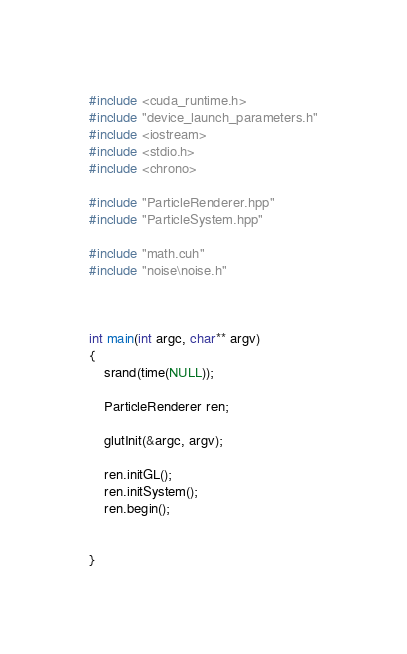Convert code to text. <code><loc_0><loc_0><loc_500><loc_500><_Cuda_>

#include <cuda_runtime.h>
#include "device_launch_parameters.h"
#include <iostream>
#include <stdio.h>
#include <chrono>

#include "ParticleRenderer.hpp"
#include "ParticleSystem.hpp"

#include "math.cuh"
#include "noise\noise.h"



int main(int argc, char** argv)
{
	srand(time(NULL));

	ParticleRenderer ren;

	glutInit(&argc, argv);

	ren.initGL();
	ren.initSystem();
	ren.begin();

	
}</code> 